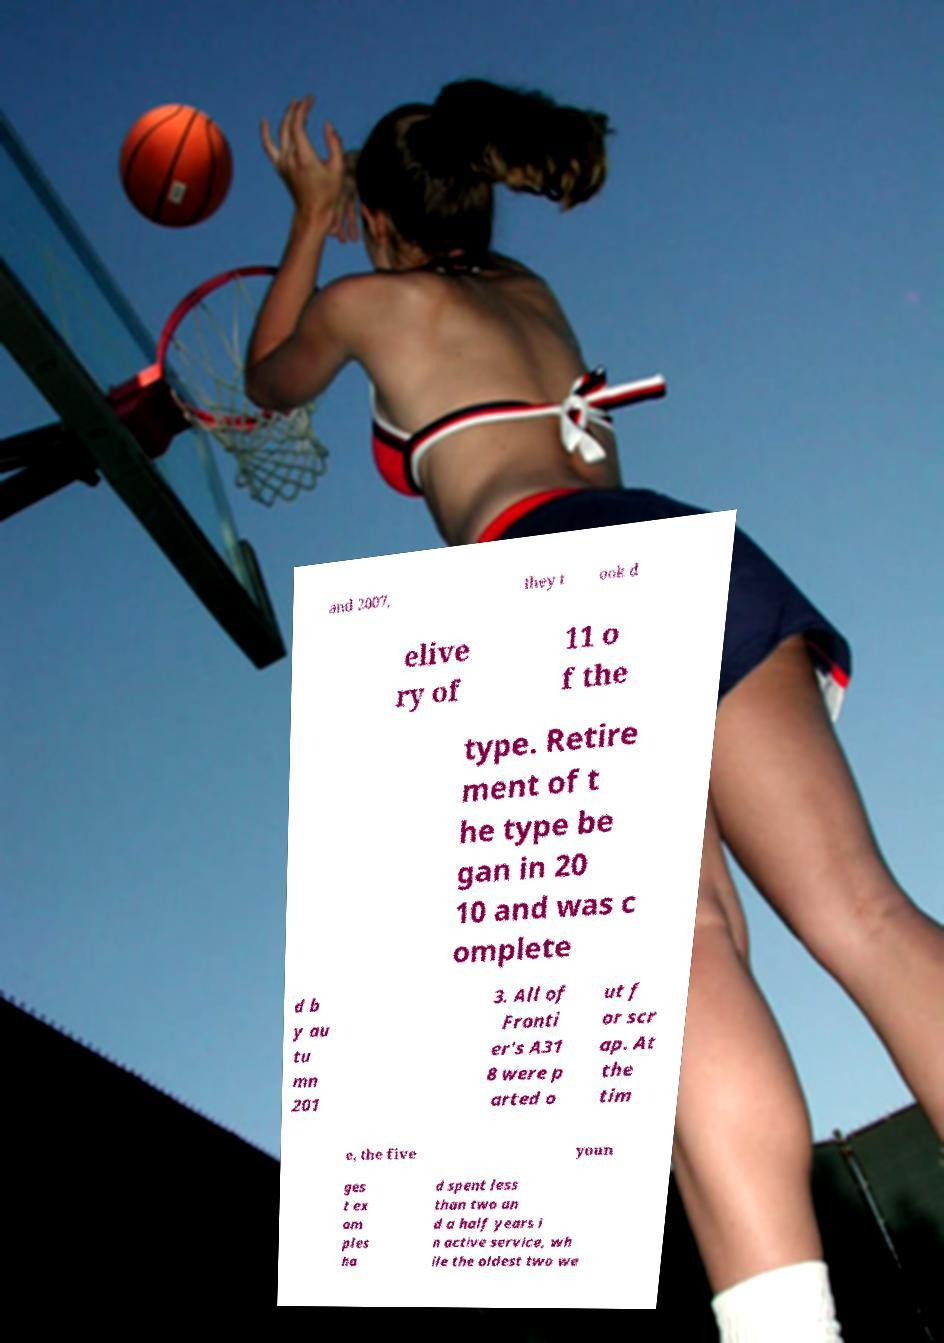Please identify and transcribe the text found in this image. and 2007, they t ook d elive ry of 11 o f the type. Retire ment of t he type be gan in 20 10 and was c omplete d b y au tu mn 201 3. All of Fronti er's A31 8 were p arted o ut f or scr ap. At the tim e, the five youn ges t ex am ples ha d spent less than two an d a half years i n active service, wh ile the oldest two we 